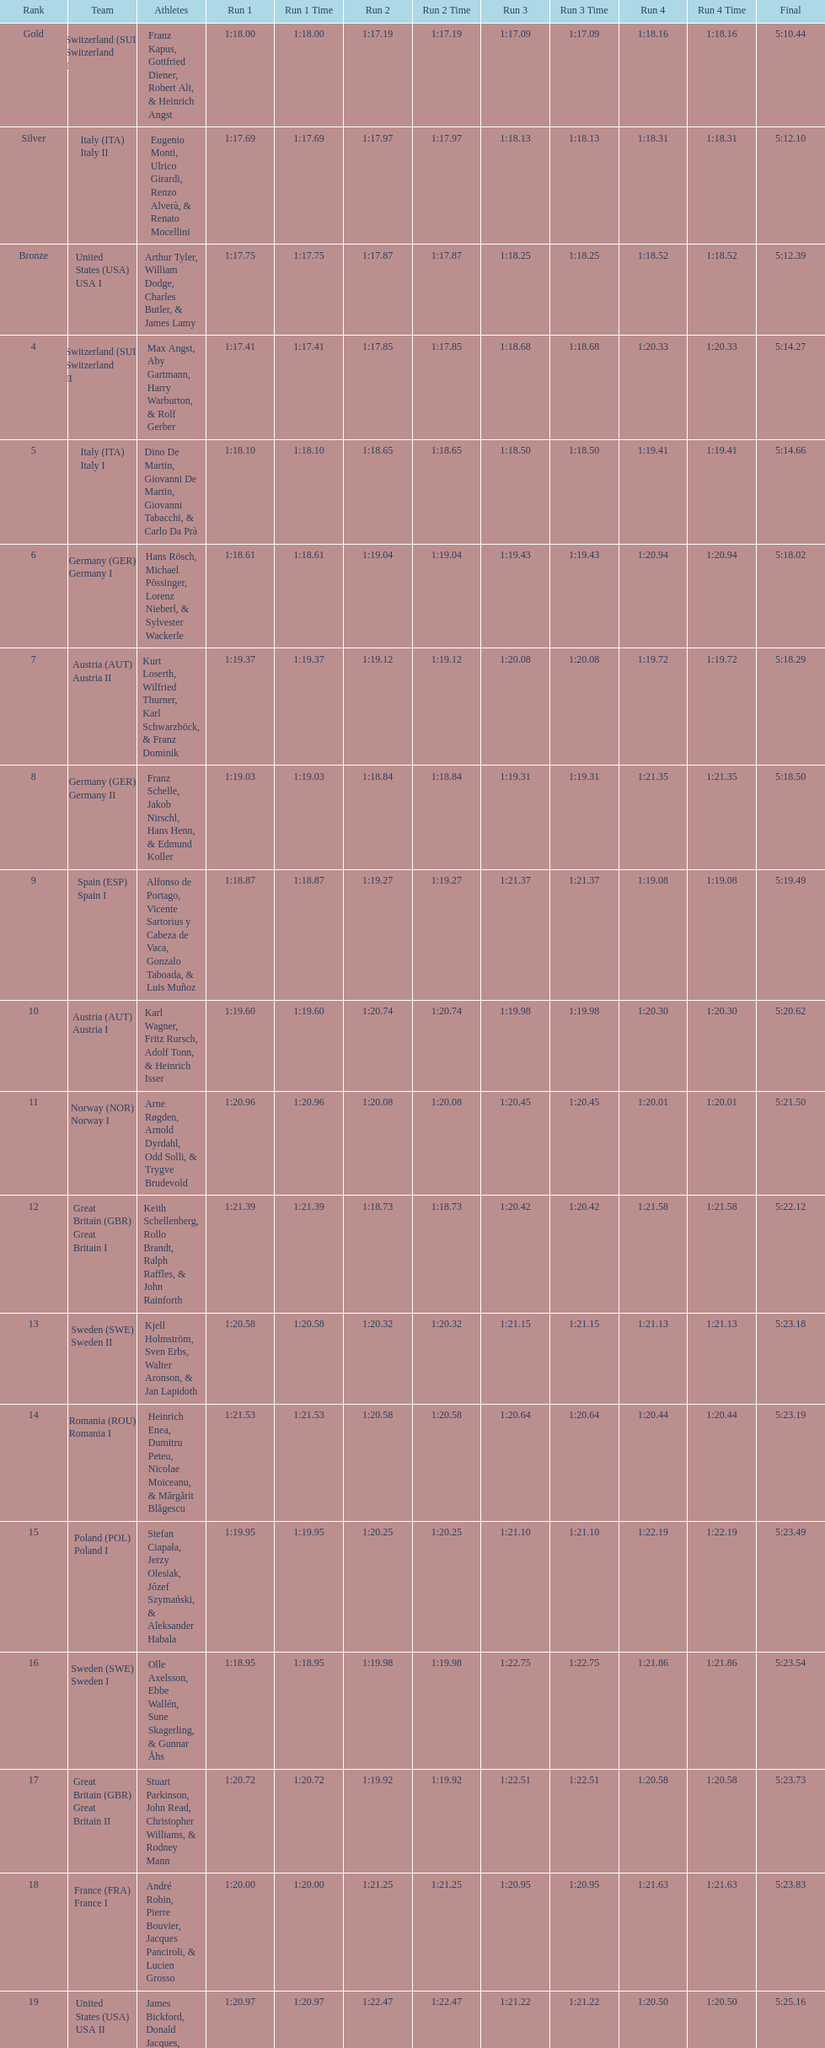Which team had the most time? Poland. 